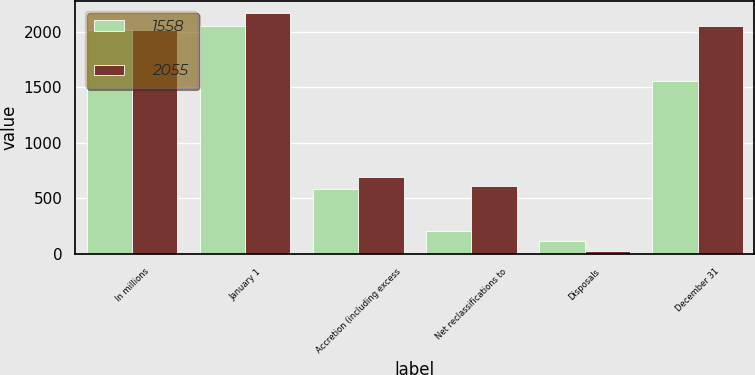<chart> <loc_0><loc_0><loc_500><loc_500><stacked_bar_chart><ecel><fcel>In millions<fcel>January 1<fcel>Accretion (including excess<fcel>Net reclassifications to<fcel>Disposals<fcel>December 31<nl><fcel>1558<fcel>2014<fcel>2055<fcel>587<fcel>208<fcel>118<fcel>1558<nl><fcel>2055<fcel>2013<fcel>2166<fcel>695<fcel>613<fcel>29<fcel>2055<nl></chart> 